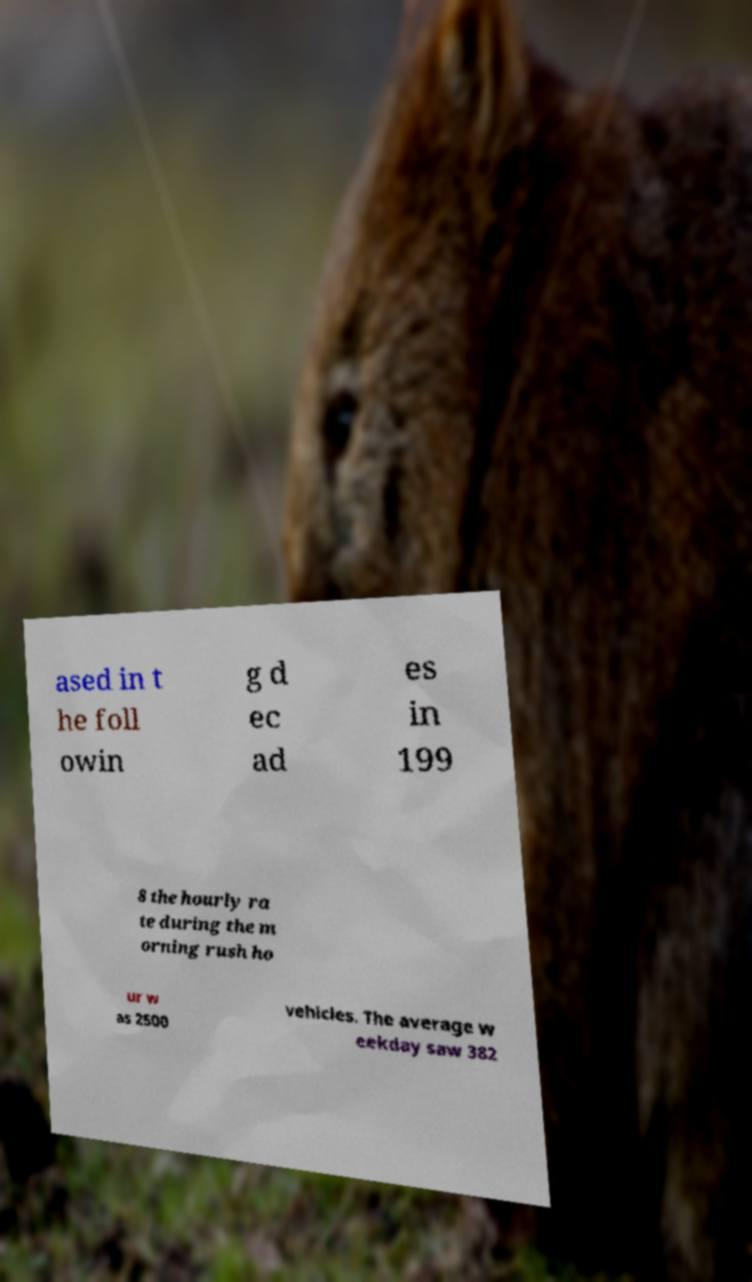Could you extract and type out the text from this image? ased in t he foll owin g d ec ad es in 199 8 the hourly ra te during the m orning rush ho ur w as 2500 vehicles. The average w eekday saw 382 